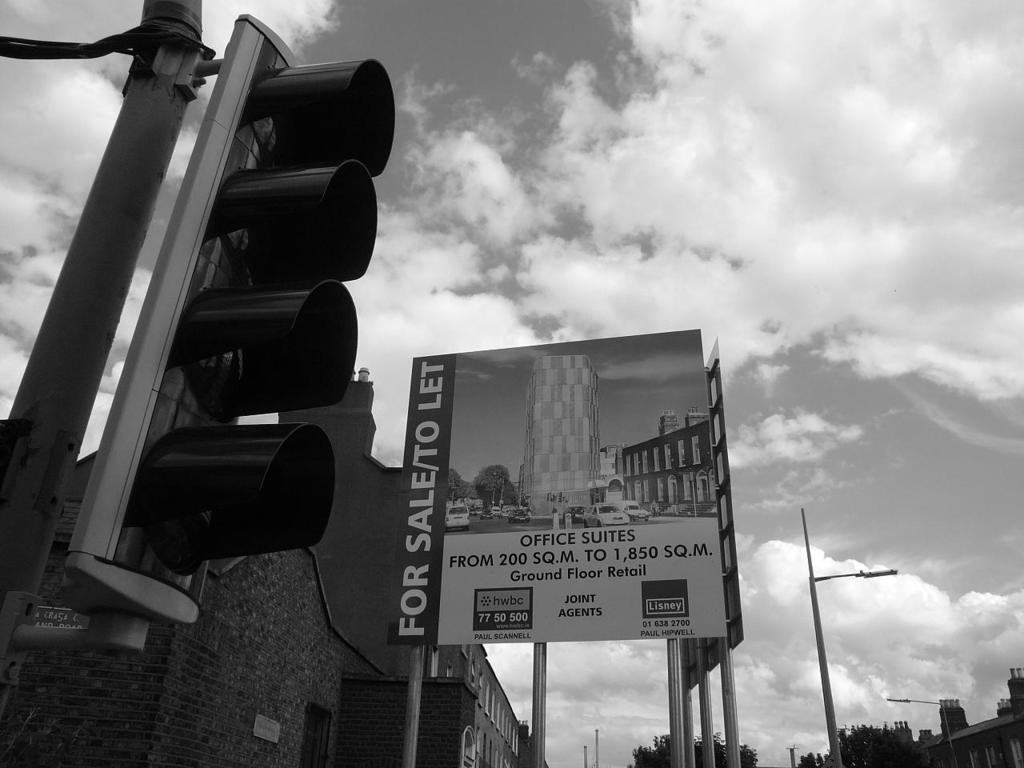That does the sign state about the buildings status?
Your response must be concise. For sale. What kind of suites does this building have?
Ensure brevity in your answer.  Office. 